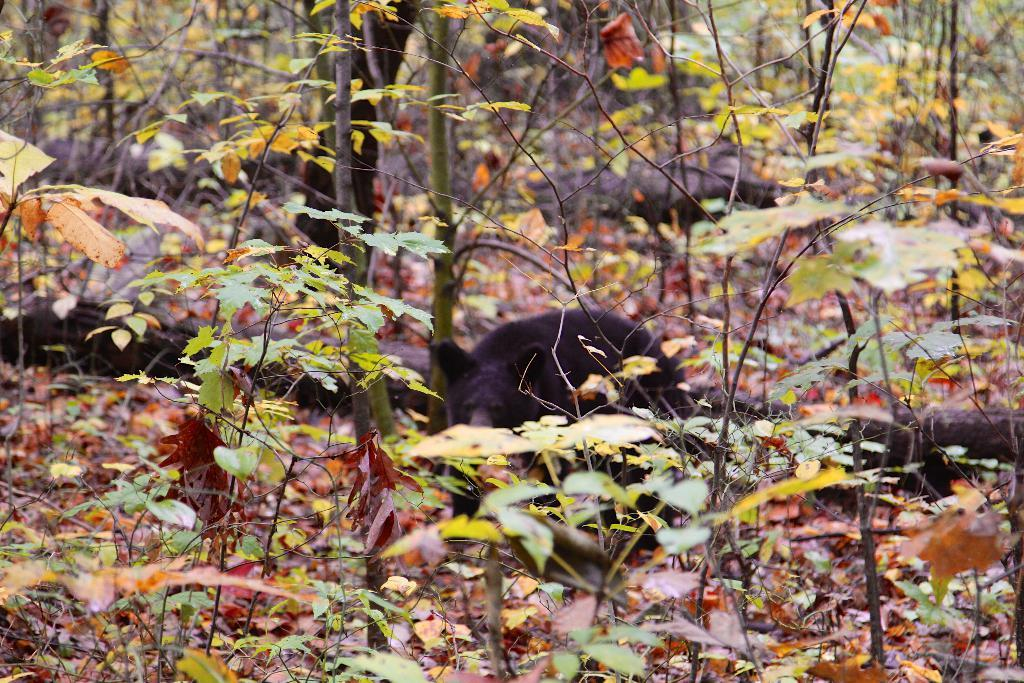What colors are the leaves in the image? The leaves in the image are green and brown in color. What animal can be seen in the background of the image? There is a black color bear in the background of the image. How would you describe the quality of the image's background? The image's background is slightly blurry. What day of the week is depicted in the image? There is no day of the week depicted in the image; it features leaves and a bear. How many teeth can be seen on the bear in the image? There are no teeth visible on the bear in the image, as bears typically do not have visible teeth when they are not actively using them. 